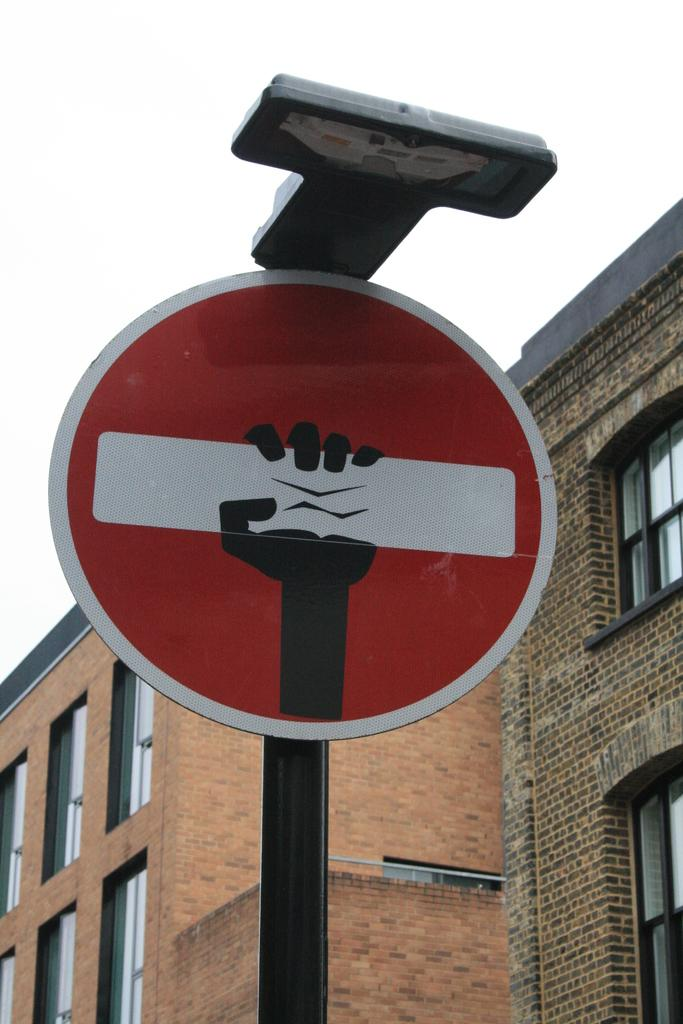What is the main object in the image? There is a pole in the image. What is attached to the pole? There is a red color sign board on the pole. What can be seen in the background of the image? There is a building and the sky visible in the background of the image. What feature of the building is mentioned in the facts? The building has windows. What type of spoon can be seen floating in space in the image? There is no spoon or space present in the image; it features a pole with a sign board, a building, and the sky. 